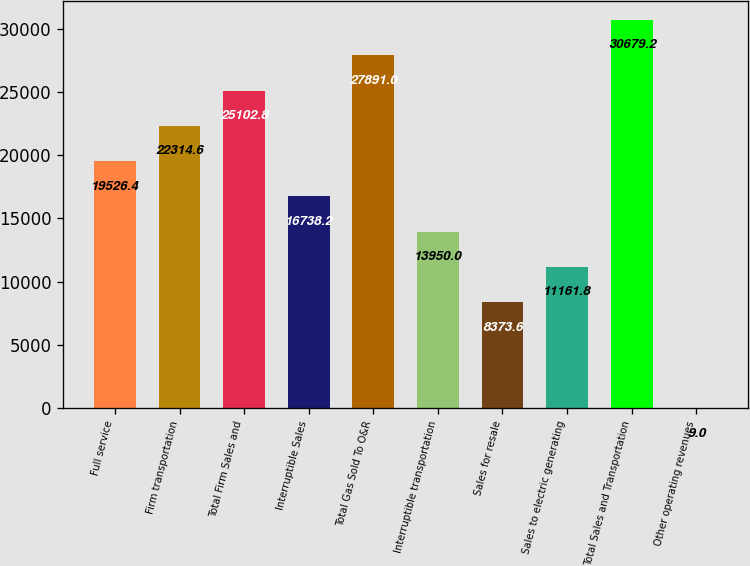Convert chart. <chart><loc_0><loc_0><loc_500><loc_500><bar_chart><fcel>Full service<fcel>Firm transportation<fcel>Total Firm Sales and<fcel>Interruptible Sales<fcel>Total Gas Sold To O&R<fcel>Interruptible transportation<fcel>Sales for resale<fcel>Sales to electric generating<fcel>Total Sales and Transportation<fcel>Other operating revenues<nl><fcel>19526.4<fcel>22314.6<fcel>25102.8<fcel>16738.2<fcel>27891<fcel>13950<fcel>8373.6<fcel>11161.8<fcel>30679.2<fcel>9<nl></chart> 